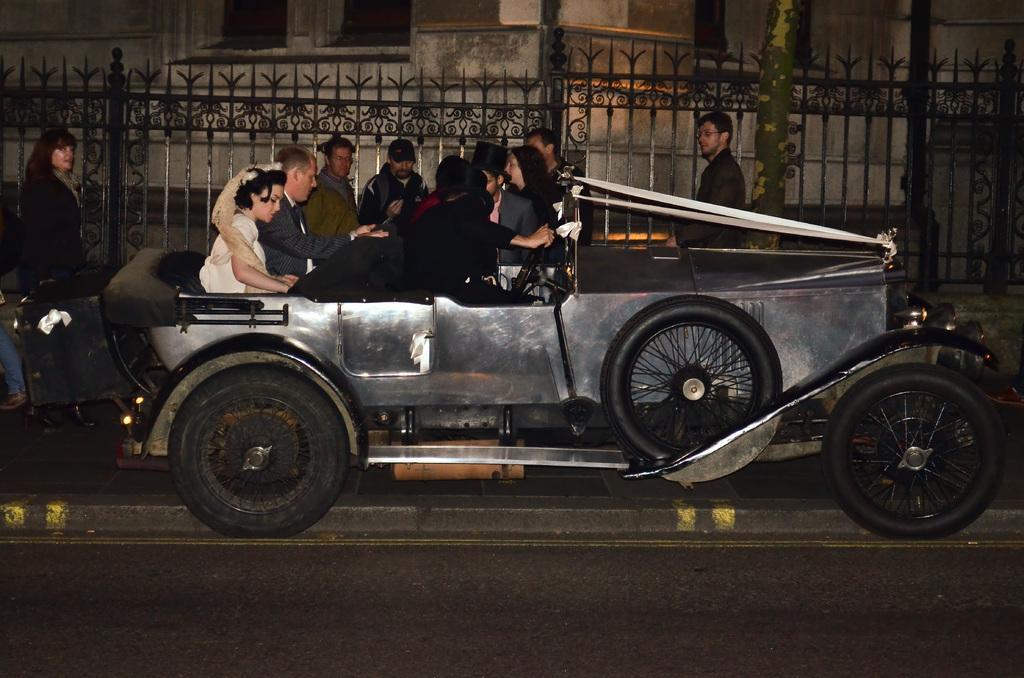In one or two sentences, can you explain what this image depicts? In this image, There is a road which is in black color, In the middle there is a car which is in black and ash color, There are some people sitting in the car, In the background there are some people walking, There are some black color grills and there is a white color wall. 